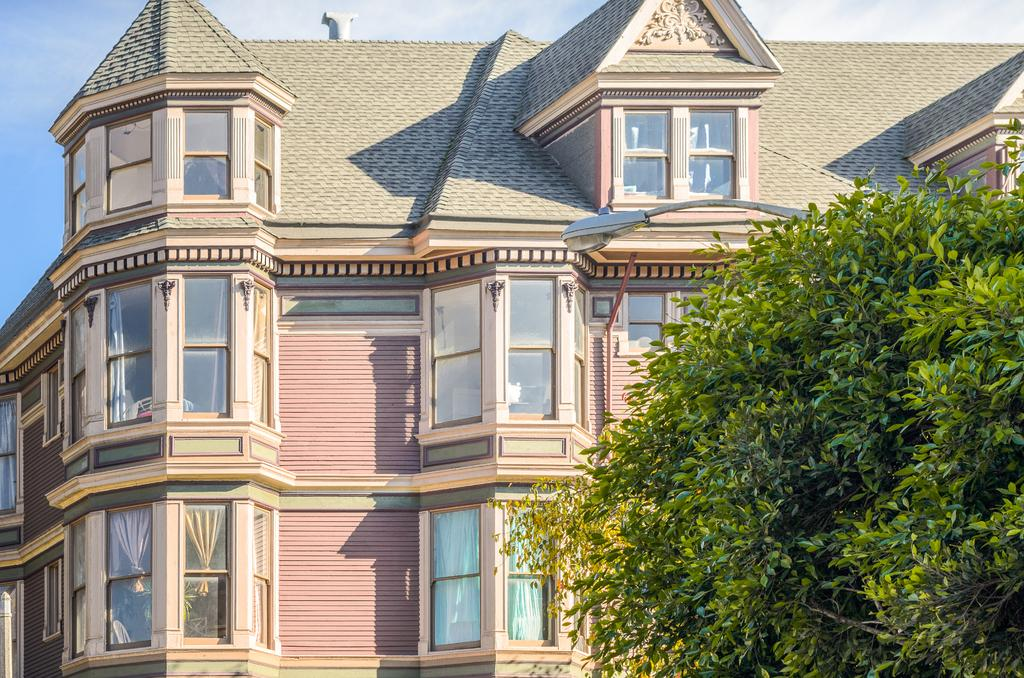What type of structure is present in the image? There is a building in the image. What feature of the building is mentioned in the facts? The building has many windows. What natural element is visible in the image? There is a tree in the image. How would you describe the sky in the image? The sky is blue and slightly cloudy in the image. Where is the station located in the image? There is no station present in the image. What type of tray is visible in the image? There is no tray present in the image. 